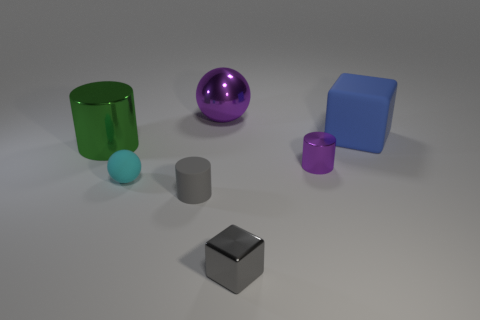Subtract all metal cylinders. How many cylinders are left? 1 Add 1 gray blocks. How many objects exist? 8 Subtract all blocks. How many objects are left? 5 Add 1 big blue matte cubes. How many big blue matte cubes exist? 2 Subtract 0 purple cubes. How many objects are left? 7 Subtract all purple shiny cylinders. Subtract all large blue things. How many objects are left? 5 Add 2 small metal cubes. How many small metal cubes are left? 3 